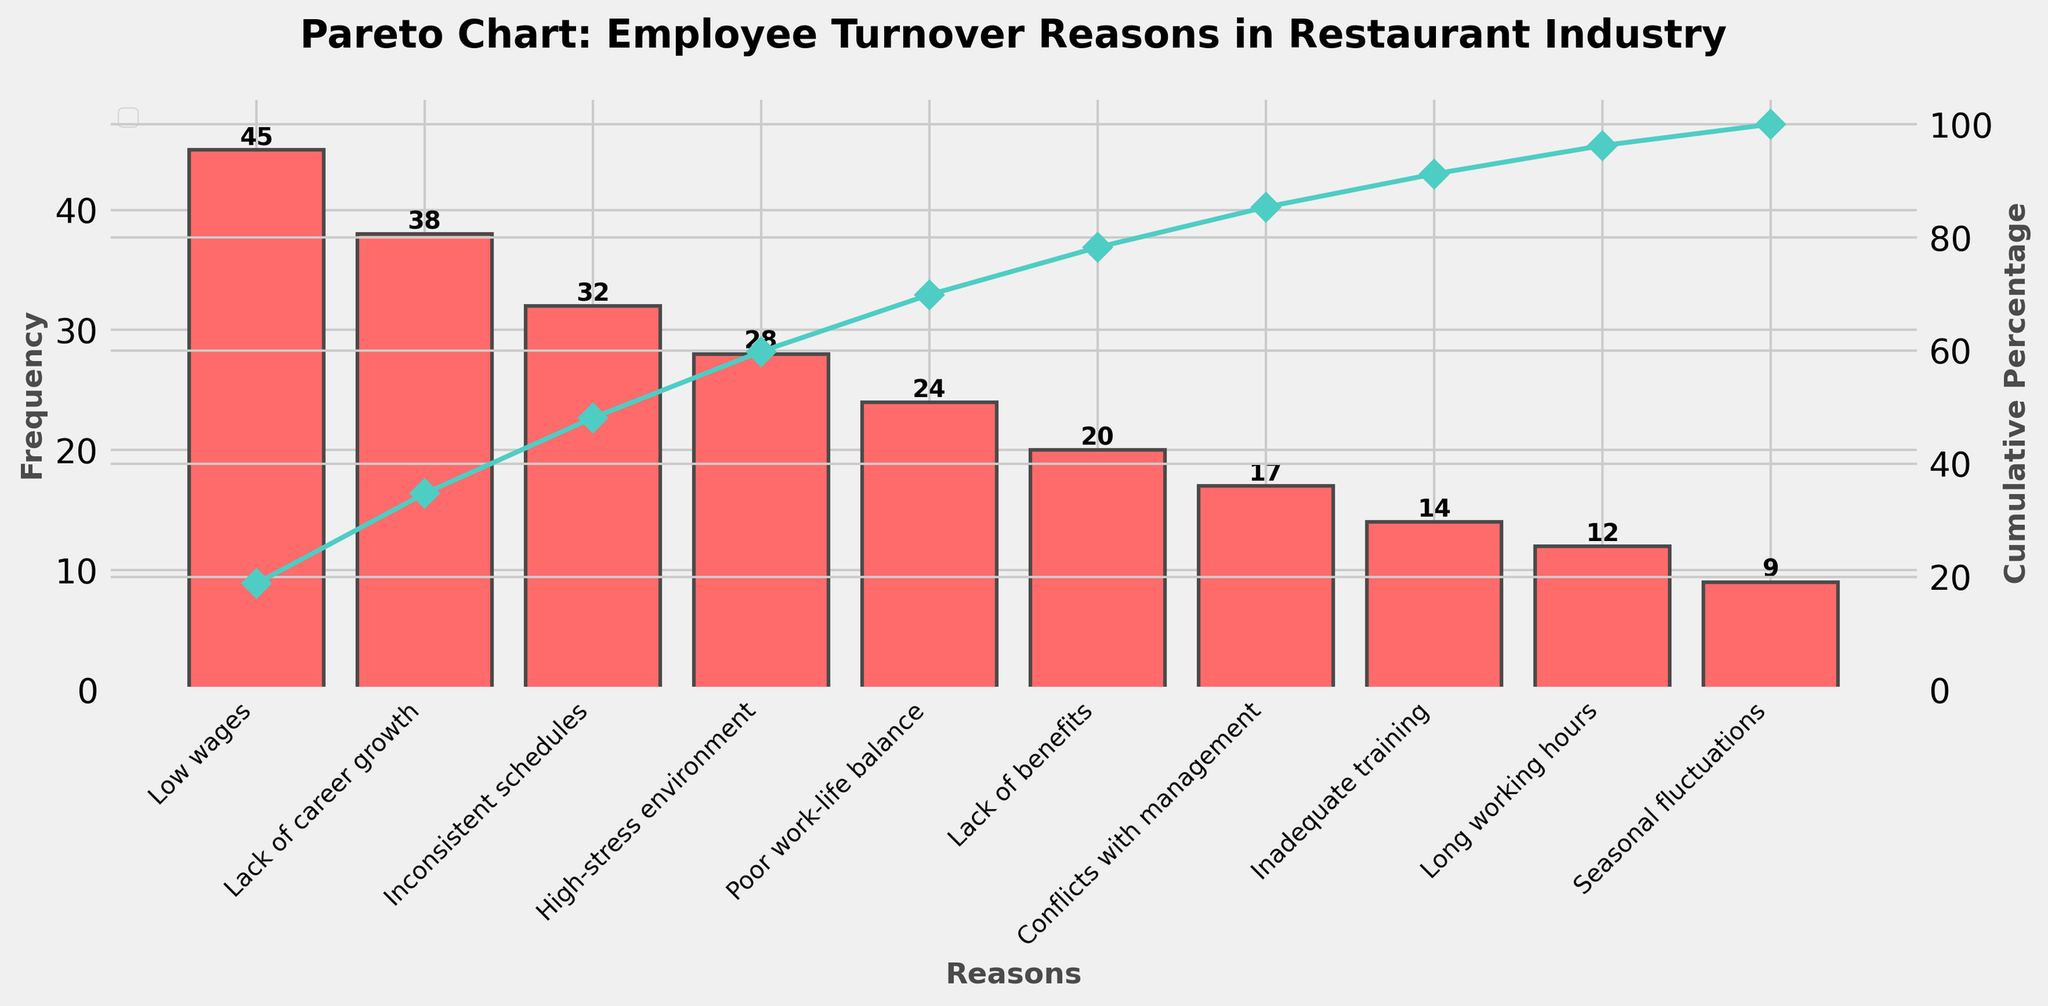What is the most common reason for employee turnover in the restaurant industry? The bar chart shows the frequency of each reason for employee turnover. The highest bar represents the most common reason.
Answer: Low wages How many reasons have a frequency equal to or greater than 24? Look for bars with a height equal to or exceeding 24. Count these bars.
Answer: 5 Which reason has the lowest frequency for employee turnover? Find the bar with the shortest height on the chart.
Answer: Seasonal fluctuations What percentage of employee turnover reasons is accounted for by the top three reasons? The line chart shows cumulative percentages. Find the cumulative percentage at the third data point.
Answer: Approximately 61% What is the cumulative percentage after the fourth reason? The cumulative percentage is marked on the line chart. Identify the percentage at the fourth data point.
Answer: Approximately 76% How does the frequency of "High-stress environment" compare to "Conflicts with management"? Compare the height of the bars for these two reasons to see which one is higher.
Answer: High-stress environment has a higher frequency What is the cumulative percentage of reasons related to "Long working hours" and "Seasonal fluctuations" combined? Find each reason's cumulative percentage from the line chart and sum them up. "Long working hours" is at 96%, and "Seasonal fluctuations" follow immediately, making the sum approximately 105% but capped at 100%.
Answer: 100% How much higher is the frequency of "Inconsistent schedules" compared to "Long working hours"? Subtract the frequency of "Long working hours" from "Inconsistent schedules".
Answer: 20 What are the two leading reasons contributing to over 50% of employee turnover? Find the point on the cumulative percentage line chart that first exceeds 50%, then check the corresponding reasons.
Answer: Low wages, Lack of career growth What is the total frequency of employee turnover reasons represented in the chart? The total frequency is the sum of all individual frequencies. Sum all the values up: 45 + 38 + 32 + 28 + 24 + 20 + 17 + 14 + 12 + 9.
Answer: 239 